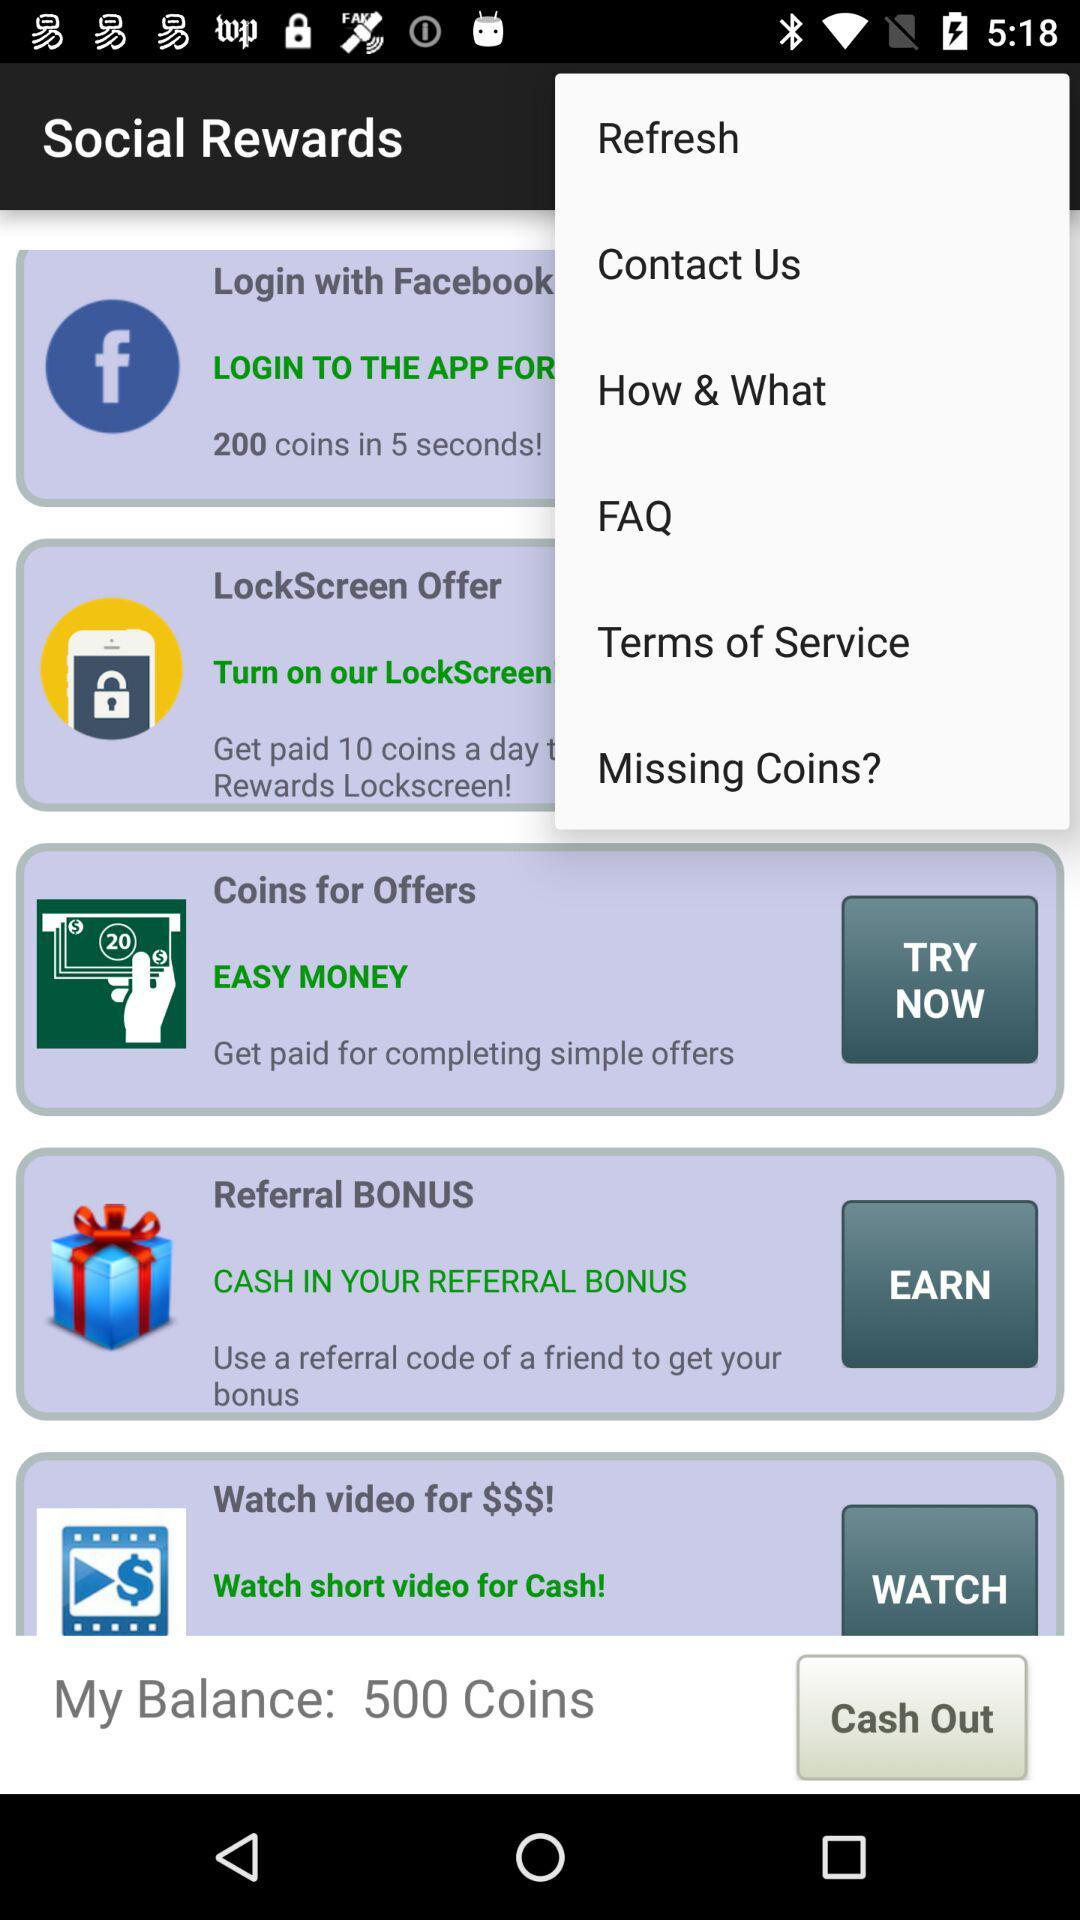How many coins do I have?
Answer the question using a single word or phrase. 500 